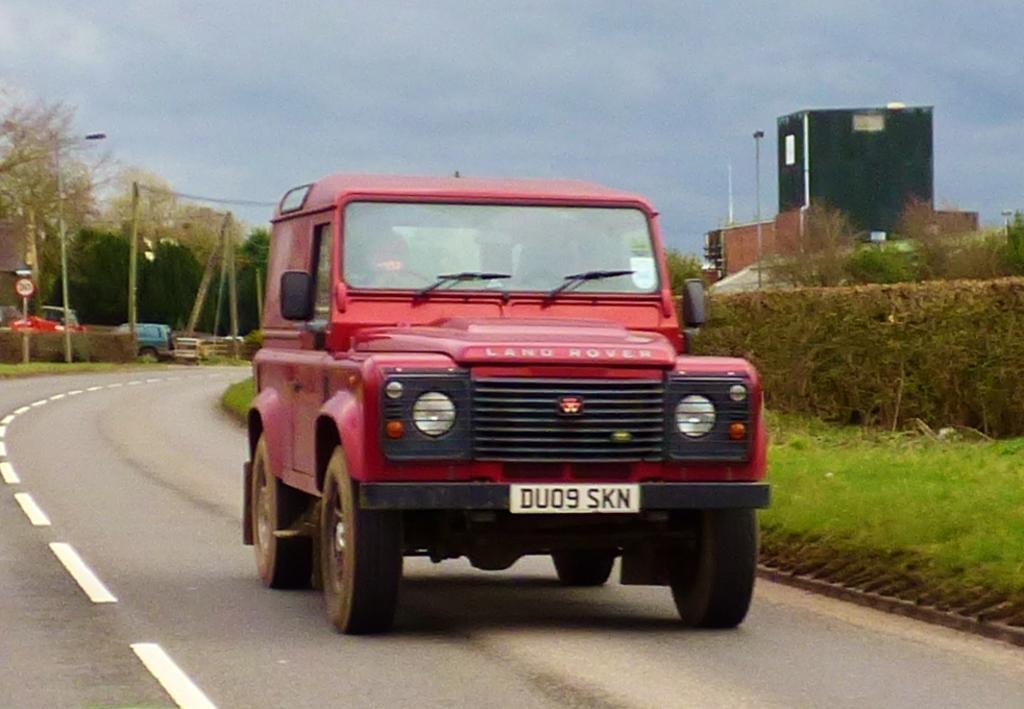In one or two sentences, can you explain what this image depicts? In the image we can see there is a vehicle parked on the road and there is a ground covered with grass. Behind there are trees and there are buildings. There is clear sky on the top. 